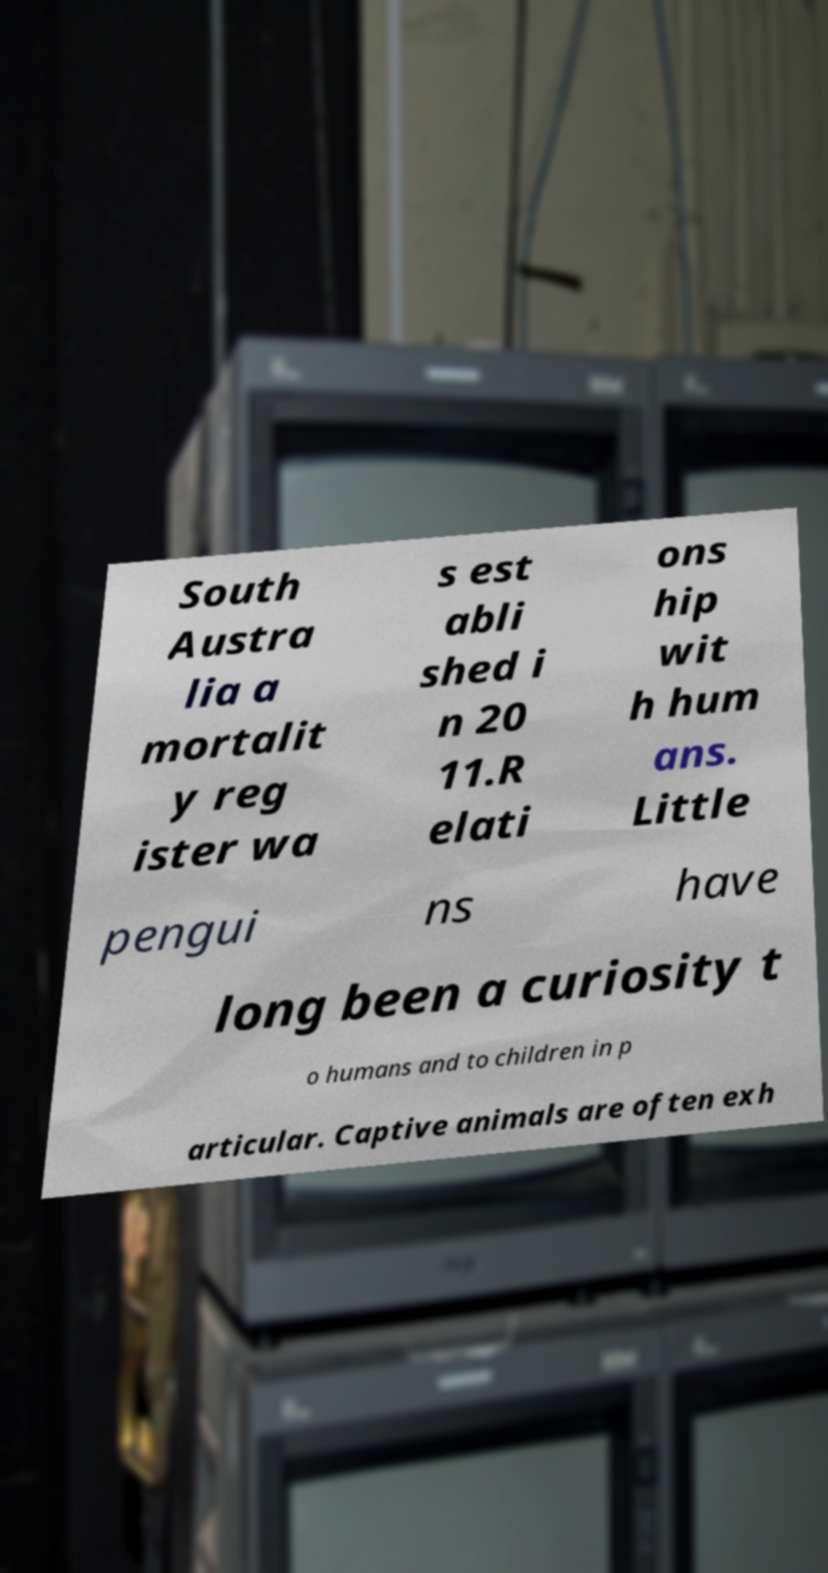Could you extract and type out the text from this image? South Austra lia a mortalit y reg ister wa s est abli shed i n 20 11.R elati ons hip wit h hum ans. Little pengui ns have long been a curiosity t o humans and to children in p articular. Captive animals are often exh 